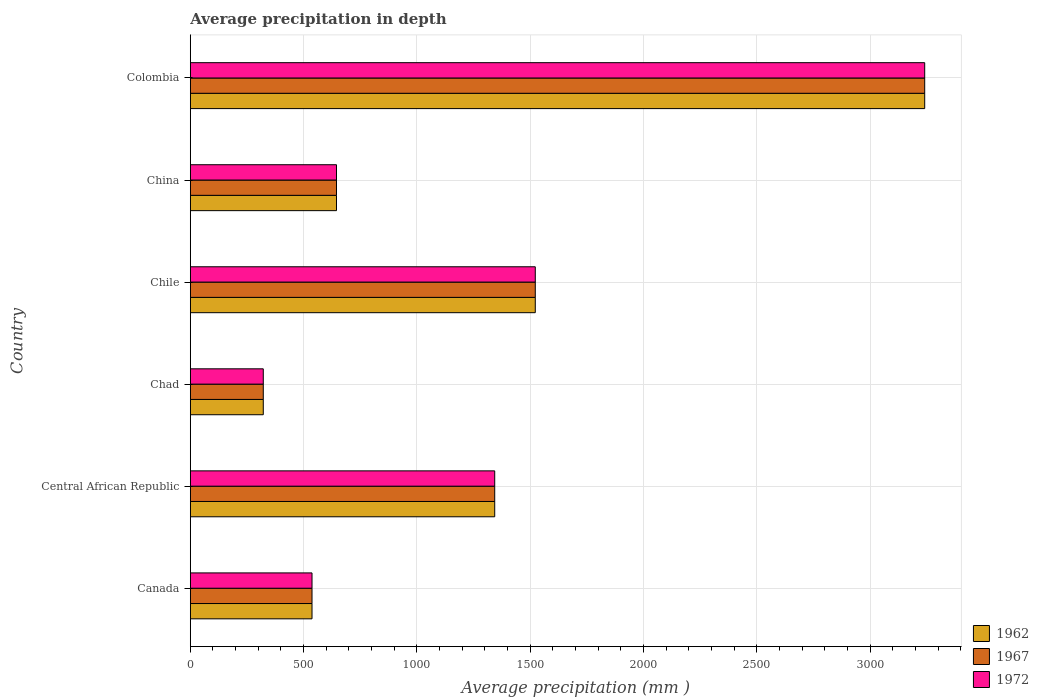How many groups of bars are there?
Give a very brief answer. 6. Are the number of bars per tick equal to the number of legend labels?
Provide a short and direct response. Yes. What is the label of the 5th group of bars from the top?
Provide a short and direct response. Central African Republic. In how many cases, is the number of bars for a given country not equal to the number of legend labels?
Your answer should be very brief. 0. What is the average precipitation in 1967 in Chile?
Give a very brief answer. 1522. Across all countries, what is the maximum average precipitation in 1972?
Offer a terse response. 3240. Across all countries, what is the minimum average precipitation in 1962?
Your answer should be very brief. 322. In which country was the average precipitation in 1962 minimum?
Your response must be concise. Chad. What is the total average precipitation in 1972 in the graph?
Your answer should be very brief. 7609. What is the difference between the average precipitation in 1972 in Central African Republic and that in Chad?
Ensure brevity in your answer.  1021. What is the difference between the average precipitation in 1962 in Central African Republic and the average precipitation in 1972 in Chile?
Offer a very short reply. -179. What is the average average precipitation in 1972 per country?
Your answer should be compact. 1268.17. What is the difference between the average precipitation in 1962 and average precipitation in 1972 in Colombia?
Make the answer very short. 0. In how many countries, is the average precipitation in 1962 greater than 1800 mm?
Your response must be concise. 1. What is the ratio of the average precipitation in 1962 in Canada to that in Chad?
Your response must be concise. 1.67. Is the average precipitation in 1967 in Central African Republic less than that in China?
Offer a terse response. No. What is the difference between the highest and the second highest average precipitation in 1962?
Your response must be concise. 1718. What is the difference between the highest and the lowest average precipitation in 1972?
Offer a very short reply. 2918. What does the 2nd bar from the top in Central African Republic represents?
Offer a terse response. 1967. Is it the case that in every country, the sum of the average precipitation in 1967 and average precipitation in 1972 is greater than the average precipitation in 1962?
Your answer should be very brief. Yes. How many bars are there?
Provide a succinct answer. 18. How many countries are there in the graph?
Keep it short and to the point. 6. What is the difference between two consecutive major ticks on the X-axis?
Your response must be concise. 500. Are the values on the major ticks of X-axis written in scientific E-notation?
Offer a very short reply. No. Does the graph contain any zero values?
Make the answer very short. No. Does the graph contain grids?
Provide a succinct answer. Yes. Where does the legend appear in the graph?
Provide a succinct answer. Bottom right. How many legend labels are there?
Provide a short and direct response. 3. How are the legend labels stacked?
Make the answer very short. Vertical. What is the title of the graph?
Keep it short and to the point. Average precipitation in depth. Does "1991" appear as one of the legend labels in the graph?
Your answer should be compact. No. What is the label or title of the X-axis?
Your response must be concise. Average precipitation (mm ). What is the Average precipitation (mm ) of 1962 in Canada?
Your response must be concise. 537. What is the Average precipitation (mm ) in 1967 in Canada?
Ensure brevity in your answer.  537. What is the Average precipitation (mm ) in 1972 in Canada?
Your response must be concise. 537. What is the Average precipitation (mm ) of 1962 in Central African Republic?
Make the answer very short. 1343. What is the Average precipitation (mm ) of 1967 in Central African Republic?
Provide a succinct answer. 1343. What is the Average precipitation (mm ) of 1972 in Central African Republic?
Your answer should be very brief. 1343. What is the Average precipitation (mm ) of 1962 in Chad?
Keep it short and to the point. 322. What is the Average precipitation (mm ) in 1967 in Chad?
Offer a very short reply. 322. What is the Average precipitation (mm ) of 1972 in Chad?
Ensure brevity in your answer.  322. What is the Average precipitation (mm ) in 1962 in Chile?
Keep it short and to the point. 1522. What is the Average precipitation (mm ) in 1967 in Chile?
Provide a succinct answer. 1522. What is the Average precipitation (mm ) in 1972 in Chile?
Make the answer very short. 1522. What is the Average precipitation (mm ) of 1962 in China?
Offer a very short reply. 645. What is the Average precipitation (mm ) in 1967 in China?
Your answer should be very brief. 645. What is the Average precipitation (mm ) of 1972 in China?
Offer a terse response. 645. What is the Average precipitation (mm ) of 1962 in Colombia?
Your answer should be compact. 3240. What is the Average precipitation (mm ) of 1967 in Colombia?
Provide a short and direct response. 3240. What is the Average precipitation (mm ) in 1972 in Colombia?
Your answer should be very brief. 3240. Across all countries, what is the maximum Average precipitation (mm ) of 1962?
Keep it short and to the point. 3240. Across all countries, what is the maximum Average precipitation (mm ) of 1967?
Ensure brevity in your answer.  3240. Across all countries, what is the maximum Average precipitation (mm ) of 1972?
Offer a terse response. 3240. Across all countries, what is the minimum Average precipitation (mm ) of 1962?
Offer a terse response. 322. Across all countries, what is the minimum Average precipitation (mm ) of 1967?
Ensure brevity in your answer.  322. Across all countries, what is the minimum Average precipitation (mm ) of 1972?
Offer a terse response. 322. What is the total Average precipitation (mm ) in 1962 in the graph?
Ensure brevity in your answer.  7609. What is the total Average precipitation (mm ) in 1967 in the graph?
Your response must be concise. 7609. What is the total Average precipitation (mm ) of 1972 in the graph?
Ensure brevity in your answer.  7609. What is the difference between the Average precipitation (mm ) in 1962 in Canada and that in Central African Republic?
Keep it short and to the point. -806. What is the difference between the Average precipitation (mm ) of 1967 in Canada and that in Central African Republic?
Ensure brevity in your answer.  -806. What is the difference between the Average precipitation (mm ) in 1972 in Canada and that in Central African Republic?
Provide a succinct answer. -806. What is the difference between the Average precipitation (mm ) of 1962 in Canada and that in Chad?
Give a very brief answer. 215. What is the difference between the Average precipitation (mm ) in 1967 in Canada and that in Chad?
Offer a very short reply. 215. What is the difference between the Average precipitation (mm ) of 1972 in Canada and that in Chad?
Provide a short and direct response. 215. What is the difference between the Average precipitation (mm ) in 1962 in Canada and that in Chile?
Make the answer very short. -985. What is the difference between the Average precipitation (mm ) in 1967 in Canada and that in Chile?
Give a very brief answer. -985. What is the difference between the Average precipitation (mm ) in 1972 in Canada and that in Chile?
Give a very brief answer. -985. What is the difference between the Average precipitation (mm ) of 1962 in Canada and that in China?
Make the answer very short. -108. What is the difference between the Average precipitation (mm ) of 1967 in Canada and that in China?
Your answer should be compact. -108. What is the difference between the Average precipitation (mm ) in 1972 in Canada and that in China?
Your answer should be very brief. -108. What is the difference between the Average precipitation (mm ) in 1962 in Canada and that in Colombia?
Make the answer very short. -2703. What is the difference between the Average precipitation (mm ) in 1967 in Canada and that in Colombia?
Your answer should be compact. -2703. What is the difference between the Average precipitation (mm ) of 1972 in Canada and that in Colombia?
Your response must be concise. -2703. What is the difference between the Average precipitation (mm ) of 1962 in Central African Republic and that in Chad?
Your response must be concise. 1021. What is the difference between the Average precipitation (mm ) in 1967 in Central African Republic and that in Chad?
Your answer should be very brief. 1021. What is the difference between the Average precipitation (mm ) of 1972 in Central African Republic and that in Chad?
Make the answer very short. 1021. What is the difference between the Average precipitation (mm ) in 1962 in Central African Republic and that in Chile?
Offer a very short reply. -179. What is the difference between the Average precipitation (mm ) in 1967 in Central African Republic and that in Chile?
Your answer should be compact. -179. What is the difference between the Average precipitation (mm ) of 1972 in Central African Republic and that in Chile?
Offer a very short reply. -179. What is the difference between the Average precipitation (mm ) of 1962 in Central African Republic and that in China?
Make the answer very short. 698. What is the difference between the Average precipitation (mm ) in 1967 in Central African Republic and that in China?
Give a very brief answer. 698. What is the difference between the Average precipitation (mm ) of 1972 in Central African Republic and that in China?
Offer a very short reply. 698. What is the difference between the Average precipitation (mm ) of 1962 in Central African Republic and that in Colombia?
Give a very brief answer. -1897. What is the difference between the Average precipitation (mm ) of 1967 in Central African Republic and that in Colombia?
Give a very brief answer. -1897. What is the difference between the Average precipitation (mm ) of 1972 in Central African Republic and that in Colombia?
Provide a short and direct response. -1897. What is the difference between the Average precipitation (mm ) in 1962 in Chad and that in Chile?
Make the answer very short. -1200. What is the difference between the Average precipitation (mm ) in 1967 in Chad and that in Chile?
Provide a succinct answer. -1200. What is the difference between the Average precipitation (mm ) in 1972 in Chad and that in Chile?
Your answer should be very brief. -1200. What is the difference between the Average precipitation (mm ) of 1962 in Chad and that in China?
Offer a terse response. -323. What is the difference between the Average precipitation (mm ) in 1967 in Chad and that in China?
Provide a succinct answer. -323. What is the difference between the Average precipitation (mm ) in 1972 in Chad and that in China?
Offer a terse response. -323. What is the difference between the Average precipitation (mm ) in 1962 in Chad and that in Colombia?
Offer a very short reply. -2918. What is the difference between the Average precipitation (mm ) in 1967 in Chad and that in Colombia?
Offer a very short reply. -2918. What is the difference between the Average precipitation (mm ) of 1972 in Chad and that in Colombia?
Your answer should be very brief. -2918. What is the difference between the Average precipitation (mm ) of 1962 in Chile and that in China?
Give a very brief answer. 877. What is the difference between the Average precipitation (mm ) of 1967 in Chile and that in China?
Make the answer very short. 877. What is the difference between the Average precipitation (mm ) of 1972 in Chile and that in China?
Offer a terse response. 877. What is the difference between the Average precipitation (mm ) of 1962 in Chile and that in Colombia?
Ensure brevity in your answer.  -1718. What is the difference between the Average precipitation (mm ) of 1967 in Chile and that in Colombia?
Provide a short and direct response. -1718. What is the difference between the Average precipitation (mm ) of 1972 in Chile and that in Colombia?
Provide a short and direct response. -1718. What is the difference between the Average precipitation (mm ) in 1962 in China and that in Colombia?
Your answer should be compact. -2595. What is the difference between the Average precipitation (mm ) in 1967 in China and that in Colombia?
Make the answer very short. -2595. What is the difference between the Average precipitation (mm ) in 1972 in China and that in Colombia?
Offer a terse response. -2595. What is the difference between the Average precipitation (mm ) in 1962 in Canada and the Average precipitation (mm ) in 1967 in Central African Republic?
Provide a short and direct response. -806. What is the difference between the Average precipitation (mm ) in 1962 in Canada and the Average precipitation (mm ) in 1972 in Central African Republic?
Offer a very short reply. -806. What is the difference between the Average precipitation (mm ) in 1967 in Canada and the Average precipitation (mm ) in 1972 in Central African Republic?
Make the answer very short. -806. What is the difference between the Average precipitation (mm ) in 1962 in Canada and the Average precipitation (mm ) in 1967 in Chad?
Keep it short and to the point. 215. What is the difference between the Average precipitation (mm ) of 1962 in Canada and the Average precipitation (mm ) of 1972 in Chad?
Your response must be concise. 215. What is the difference between the Average precipitation (mm ) in 1967 in Canada and the Average precipitation (mm ) in 1972 in Chad?
Keep it short and to the point. 215. What is the difference between the Average precipitation (mm ) of 1962 in Canada and the Average precipitation (mm ) of 1967 in Chile?
Your answer should be very brief. -985. What is the difference between the Average precipitation (mm ) in 1962 in Canada and the Average precipitation (mm ) in 1972 in Chile?
Provide a short and direct response. -985. What is the difference between the Average precipitation (mm ) in 1967 in Canada and the Average precipitation (mm ) in 1972 in Chile?
Provide a succinct answer. -985. What is the difference between the Average precipitation (mm ) of 1962 in Canada and the Average precipitation (mm ) of 1967 in China?
Provide a succinct answer. -108. What is the difference between the Average precipitation (mm ) of 1962 in Canada and the Average precipitation (mm ) of 1972 in China?
Your answer should be very brief. -108. What is the difference between the Average precipitation (mm ) in 1967 in Canada and the Average precipitation (mm ) in 1972 in China?
Keep it short and to the point. -108. What is the difference between the Average precipitation (mm ) of 1962 in Canada and the Average precipitation (mm ) of 1967 in Colombia?
Give a very brief answer. -2703. What is the difference between the Average precipitation (mm ) of 1962 in Canada and the Average precipitation (mm ) of 1972 in Colombia?
Keep it short and to the point. -2703. What is the difference between the Average precipitation (mm ) in 1967 in Canada and the Average precipitation (mm ) in 1972 in Colombia?
Offer a very short reply. -2703. What is the difference between the Average precipitation (mm ) in 1962 in Central African Republic and the Average precipitation (mm ) in 1967 in Chad?
Offer a very short reply. 1021. What is the difference between the Average precipitation (mm ) in 1962 in Central African Republic and the Average precipitation (mm ) in 1972 in Chad?
Keep it short and to the point. 1021. What is the difference between the Average precipitation (mm ) of 1967 in Central African Republic and the Average precipitation (mm ) of 1972 in Chad?
Keep it short and to the point. 1021. What is the difference between the Average precipitation (mm ) of 1962 in Central African Republic and the Average precipitation (mm ) of 1967 in Chile?
Give a very brief answer. -179. What is the difference between the Average precipitation (mm ) of 1962 in Central African Republic and the Average precipitation (mm ) of 1972 in Chile?
Give a very brief answer. -179. What is the difference between the Average precipitation (mm ) in 1967 in Central African Republic and the Average precipitation (mm ) in 1972 in Chile?
Offer a terse response. -179. What is the difference between the Average precipitation (mm ) of 1962 in Central African Republic and the Average precipitation (mm ) of 1967 in China?
Give a very brief answer. 698. What is the difference between the Average precipitation (mm ) in 1962 in Central African Republic and the Average precipitation (mm ) in 1972 in China?
Your answer should be compact. 698. What is the difference between the Average precipitation (mm ) in 1967 in Central African Republic and the Average precipitation (mm ) in 1972 in China?
Make the answer very short. 698. What is the difference between the Average precipitation (mm ) of 1962 in Central African Republic and the Average precipitation (mm ) of 1967 in Colombia?
Your answer should be compact. -1897. What is the difference between the Average precipitation (mm ) of 1962 in Central African Republic and the Average precipitation (mm ) of 1972 in Colombia?
Offer a very short reply. -1897. What is the difference between the Average precipitation (mm ) in 1967 in Central African Republic and the Average precipitation (mm ) in 1972 in Colombia?
Ensure brevity in your answer.  -1897. What is the difference between the Average precipitation (mm ) in 1962 in Chad and the Average precipitation (mm ) in 1967 in Chile?
Provide a short and direct response. -1200. What is the difference between the Average precipitation (mm ) of 1962 in Chad and the Average precipitation (mm ) of 1972 in Chile?
Your answer should be very brief. -1200. What is the difference between the Average precipitation (mm ) of 1967 in Chad and the Average precipitation (mm ) of 1972 in Chile?
Your answer should be compact. -1200. What is the difference between the Average precipitation (mm ) of 1962 in Chad and the Average precipitation (mm ) of 1967 in China?
Provide a short and direct response. -323. What is the difference between the Average precipitation (mm ) of 1962 in Chad and the Average precipitation (mm ) of 1972 in China?
Provide a succinct answer. -323. What is the difference between the Average precipitation (mm ) of 1967 in Chad and the Average precipitation (mm ) of 1972 in China?
Offer a terse response. -323. What is the difference between the Average precipitation (mm ) of 1962 in Chad and the Average precipitation (mm ) of 1967 in Colombia?
Provide a succinct answer. -2918. What is the difference between the Average precipitation (mm ) of 1962 in Chad and the Average precipitation (mm ) of 1972 in Colombia?
Make the answer very short. -2918. What is the difference between the Average precipitation (mm ) in 1967 in Chad and the Average precipitation (mm ) in 1972 in Colombia?
Provide a short and direct response. -2918. What is the difference between the Average precipitation (mm ) of 1962 in Chile and the Average precipitation (mm ) of 1967 in China?
Provide a short and direct response. 877. What is the difference between the Average precipitation (mm ) in 1962 in Chile and the Average precipitation (mm ) in 1972 in China?
Your response must be concise. 877. What is the difference between the Average precipitation (mm ) in 1967 in Chile and the Average precipitation (mm ) in 1972 in China?
Make the answer very short. 877. What is the difference between the Average precipitation (mm ) in 1962 in Chile and the Average precipitation (mm ) in 1967 in Colombia?
Make the answer very short. -1718. What is the difference between the Average precipitation (mm ) of 1962 in Chile and the Average precipitation (mm ) of 1972 in Colombia?
Offer a very short reply. -1718. What is the difference between the Average precipitation (mm ) in 1967 in Chile and the Average precipitation (mm ) in 1972 in Colombia?
Your response must be concise. -1718. What is the difference between the Average precipitation (mm ) in 1962 in China and the Average precipitation (mm ) in 1967 in Colombia?
Ensure brevity in your answer.  -2595. What is the difference between the Average precipitation (mm ) of 1962 in China and the Average precipitation (mm ) of 1972 in Colombia?
Your answer should be very brief. -2595. What is the difference between the Average precipitation (mm ) in 1967 in China and the Average precipitation (mm ) in 1972 in Colombia?
Provide a short and direct response. -2595. What is the average Average precipitation (mm ) in 1962 per country?
Provide a short and direct response. 1268.17. What is the average Average precipitation (mm ) of 1967 per country?
Give a very brief answer. 1268.17. What is the average Average precipitation (mm ) in 1972 per country?
Your answer should be compact. 1268.17. What is the difference between the Average precipitation (mm ) in 1962 and Average precipitation (mm ) in 1972 in Canada?
Offer a terse response. 0. What is the difference between the Average precipitation (mm ) of 1967 and Average precipitation (mm ) of 1972 in Canada?
Offer a terse response. 0. What is the difference between the Average precipitation (mm ) in 1967 and Average precipitation (mm ) in 1972 in Central African Republic?
Offer a very short reply. 0. What is the difference between the Average precipitation (mm ) in 1962 and Average precipitation (mm ) in 1972 in Chad?
Your response must be concise. 0. What is the difference between the Average precipitation (mm ) in 1967 and Average precipitation (mm ) in 1972 in Chad?
Your answer should be compact. 0. What is the difference between the Average precipitation (mm ) of 1962 and Average precipitation (mm ) of 1972 in Chile?
Keep it short and to the point. 0. What is the difference between the Average precipitation (mm ) of 1967 and Average precipitation (mm ) of 1972 in Chile?
Provide a short and direct response. 0. What is the difference between the Average precipitation (mm ) of 1967 and Average precipitation (mm ) of 1972 in China?
Offer a very short reply. 0. What is the difference between the Average precipitation (mm ) of 1962 and Average precipitation (mm ) of 1967 in Colombia?
Make the answer very short. 0. What is the ratio of the Average precipitation (mm ) in 1962 in Canada to that in Central African Republic?
Offer a terse response. 0.4. What is the ratio of the Average precipitation (mm ) of 1967 in Canada to that in Central African Republic?
Your response must be concise. 0.4. What is the ratio of the Average precipitation (mm ) in 1972 in Canada to that in Central African Republic?
Your answer should be compact. 0.4. What is the ratio of the Average precipitation (mm ) in 1962 in Canada to that in Chad?
Your answer should be very brief. 1.67. What is the ratio of the Average precipitation (mm ) in 1967 in Canada to that in Chad?
Your answer should be very brief. 1.67. What is the ratio of the Average precipitation (mm ) in 1972 in Canada to that in Chad?
Keep it short and to the point. 1.67. What is the ratio of the Average precipitation (mm ) of 1962 in Canada to that in Chile?
Your answer should be very brief. 0.35. What is the ratio of the Average precipitation (mm ) in 1967 in Canada to that in Chile?
Offer a very short reply. 0.35. What is the ratio of the Average precipitation (mm ) of 1972 in Canada to that in Chile?
Your response must be concise. 0.35. What is the ratio of the Average precipitation (mm ) in 1962 in Canada to that in China?
Offer a very short reply. 0.83. What is the ratio of the Average precipitation (mm ) in 1967 in Canada to that in China?
Make the answer very short. 0.83. What is the ratio of the Average precipitation (mm ) in 1972 in Canada to that in China?
Give a very brief answer. 0.83. What is the ratio of the Average precipitation (mm ) in 1962 in Canada to that in Colombia?
Offer a terse response. 0.17. What is the ratio of the Average precipitation (mm ) in 1967 in Canada to that in Colombia?
Make the answer very short. 0.17. What is the ratio of the Average precipitation (mm ) of 1972 in Canada to that in Colombia?
Offer a very short reply. 0.17. What is the ratio of the Average precipitation (mm ) in 1962 in Central African Republic to that in Chad?
Make the answer very short. 4.17. What is the ratio of the Average precipitation (mm ) in 1967 in Central African Republic to that in Chad?
Offer a terse response. 4.17. What is the ratio of the Average precipitation (mm ) in 1972 in Central African Republic to that in Chad?
Your response must be concise. 4.17. What is the ratio of the Average precipitation (mm ) in 1962 in Central African Republic to that in Chile?
Provide a short and direct response. 0.88. What is the ratio of the Average precipitation (mm ) of 1967 in Central African Republic to that in Chile?
Your answer should be very brief. 0.88. What is the ratio of the Average precipitation (mm ) in 1972 in Central African Republic to that in Chile?
Your answer should be very brief. 0.88. What is the ratio of the Average precipitation (mm ) in 1962 in Central African Republic to that in China?
Your answer should be compact. 2.08. What is the ratio of the Average precipitation (mm ) in 1967 in Central African Republic to that in China?
Provide a succinct answer. 2.08. What is the ratio of the Average precipitation (mm ) in 1972 in Central African Republic to that in China?
Your response must be concise. 2.08. What is the ratio of the Average precipitation (mm ) of 1962 in Central African Republic to that in Colombia?
Your answer should be compact. 0.41. What is the ratio of the Average precipitation (mm ) of 1967 in Central African Republic to that in Colombia?
Offer a terse response. 0.41. What is the ratio of the Average precipitation (mm ) of 1972 in Central African Republic to that in Colombia?
Keep it short and to the point. 0.41. What is the ratio of the Average precipitation (mm ) of 1962 in Chad to that in Chile?
Provide a succinct answer. 0.21. What is the ratio of the Average precipitation (mm ) in 1967 in Chad to that in Chile?
Give a very brief answer. 0.21. What is the ratio of the Average precipitation (mm ) of 1972 in Chad to that in Chile?
Your answer should be very brief. 0.21. What is the ratio of the Average precipitation (mm ) in 1962 in Chad to that in China?
Offer a terse response. 0.5. What is the ratio of the Average precipitation (mm ) of 1967 in Chad to that in China?
Offer a very short reply. 0.5. What is the ratio of the Average precipitation (mm ) of 1972 in Chad to that in China?
Ensure brevity in your answer.  0.5. What is the ratio of the Average precipitation (mm ) in 1962 in Chad to that in Colombia?
Ensure brevity in your answer.  0.1. What is the ratio of the Average precipitation (mm ) in 1967 in Chad to that in Colombia?
Make the answer very short. 0.1. What is the ratio of the Average precipitation (mm ) in 1972 in Chad to that in Colombia?
Give a very brief answer. 0.1. What is the ratio of the Average precipitation (mm ) of 1962 in Chile to that in China?
Provide a succinct answer. 2.36. What is the ratio of the Average precipitation (mm ) of 1967 in Chile to that in China?
Your answer should be very brief. 2.36. What is the ratio of the Average precipitation (mm ) of 1972 in Chile to that in China?
Provide a succinct answer. 2.36. What is the ratio of the Average precipitation (mm ) in 1962 in Chile to that in Colombia?
Ensure brevity in your answer.  0.47. What is the ratio of the Average precipitation (mm ) in 1967 in Chile to that in Colombia?
Provide a short and direct response. 0.47. What is the ratio of the Average precipitation (mm ) in 1972 in Chile to that in Colombia?
Offer a very short reply. 0.47. What is the ratio of the Average precipitation (mm ) of 1962 in China to that in Colombia?
Provide a succinct answer. 0.2. What is the ratio of the Average precipitation (mm ) of 1967 in China to that in Colombia?
Provide a short and direct response. 0.2. What is the ratio of the Average precipitation (mm ) of 1972 in China to that in Colombia?
Your answer should be compact. 0.2. What is the difference between the highest and the second highest Average precipitation (mm ) of 1962?
Offer a terse response. 1718. What is the difference between the highest and the second highest Average precipitation (mm ) of 1967?
Offer a terse response. 1718. What is the difference between the highest and the second highest Average precipitation (mm ) of 1972?
Offer a terse response. 1718. What is the difference between the highest and the lowest Average precipitation (mm ) of 1962?
Your response must be concise. 2918. What is the difference between the highest and the lowest Average precipitation (mm ) in 1967?
Offer a very short reply. 2918. What is the difference between the highest and the lowest Average precipitation (mm ) of 1972?
Your response must be concise. 2918. 